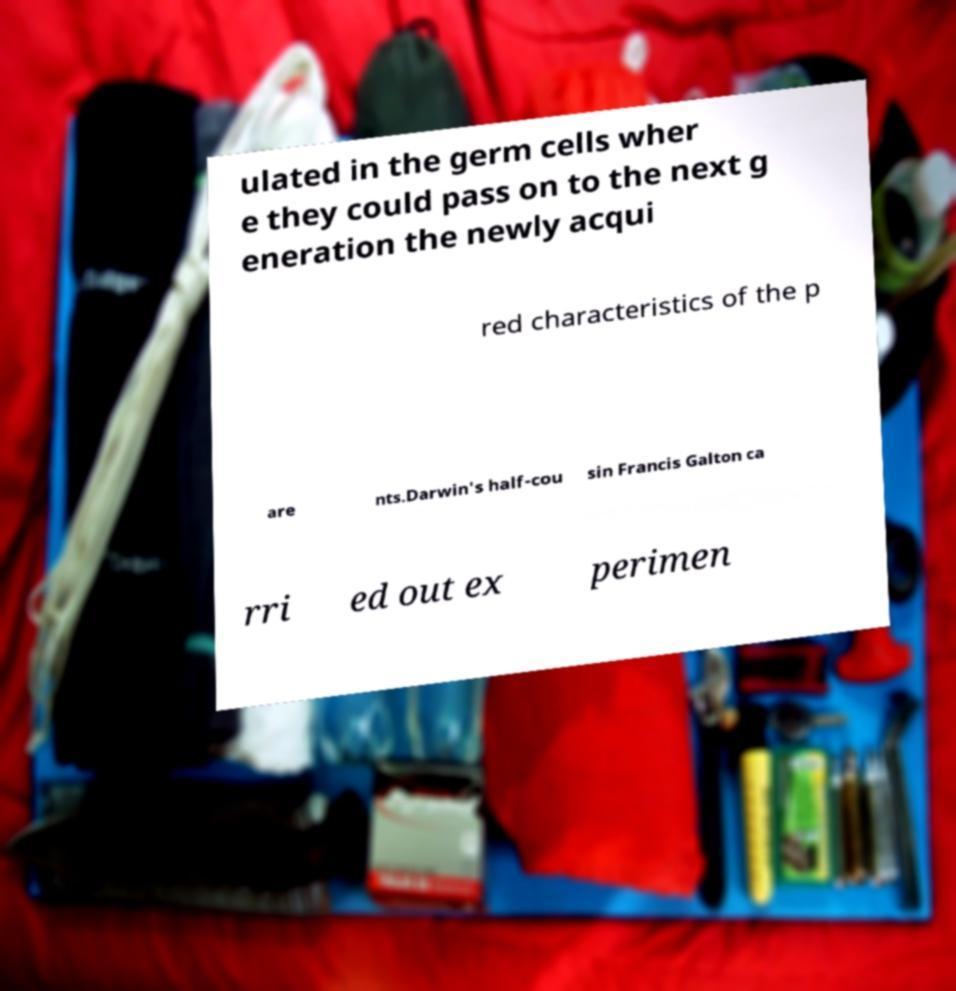Please read and relay the text visible in this image. What does it say? ulated in the germ cells wher e they could pass on to the next g eneration the newly acqui red characteristics of the p are nts.Darwin's half-cou sin Francis Galton ca rri ed out ex perimen 